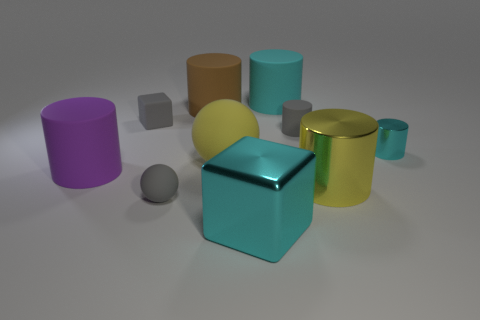Subtract all large brown matte cylinders. How many cylinders are left? 5 Subtract all purple balls. How many cyan cylinders are left? 2 Subtract all yellow cylinders. How many cylinders are left? 5 Subtract 3 cylinders. How many cylinders are left? 3 Subtract all spheres. How many objects are left? 8 Add 2 big brown matte cubes. How many big brown matte cubes exist? 2 Subtract 1 yellow spheres. How many objects are left? 9 Subtract all red cylinders. Subtract all brown cubes. How many cylinders are left? 6 Subtract all big red metal cubes. Subtract all spheres. How many objects are left? 8 Add 3 gray matte spheres. How many gray matte spheres are left? 4 